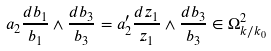Convert formula to latex. <formula><loc_0><loc_0><loc_500><loc_500>a _ { 2 } \frac { d b _ { 1 } } { b _ { 1 } } \wedge \frac { d b _ { 3 } } { b _ { 3 } } = a _ { 2 } ^ { \prime } \frac { d z _ { 1 } } { z _ { 1 } } \wedge \frac { d b _ { 3 } } { b _ { 3 } } \in \Omega ^ { 2 } _ { k / k _ { 0 } }</formula> 